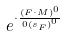Convert formula to latex. <formula><loc_0><loc_0><loc_500><loc_500>e ^ { \cdot \frac { ( F \cdot M ) ^ { 0 } } { 0 { ( s _ { F } ) } ^ { 0 } } }</formula> 